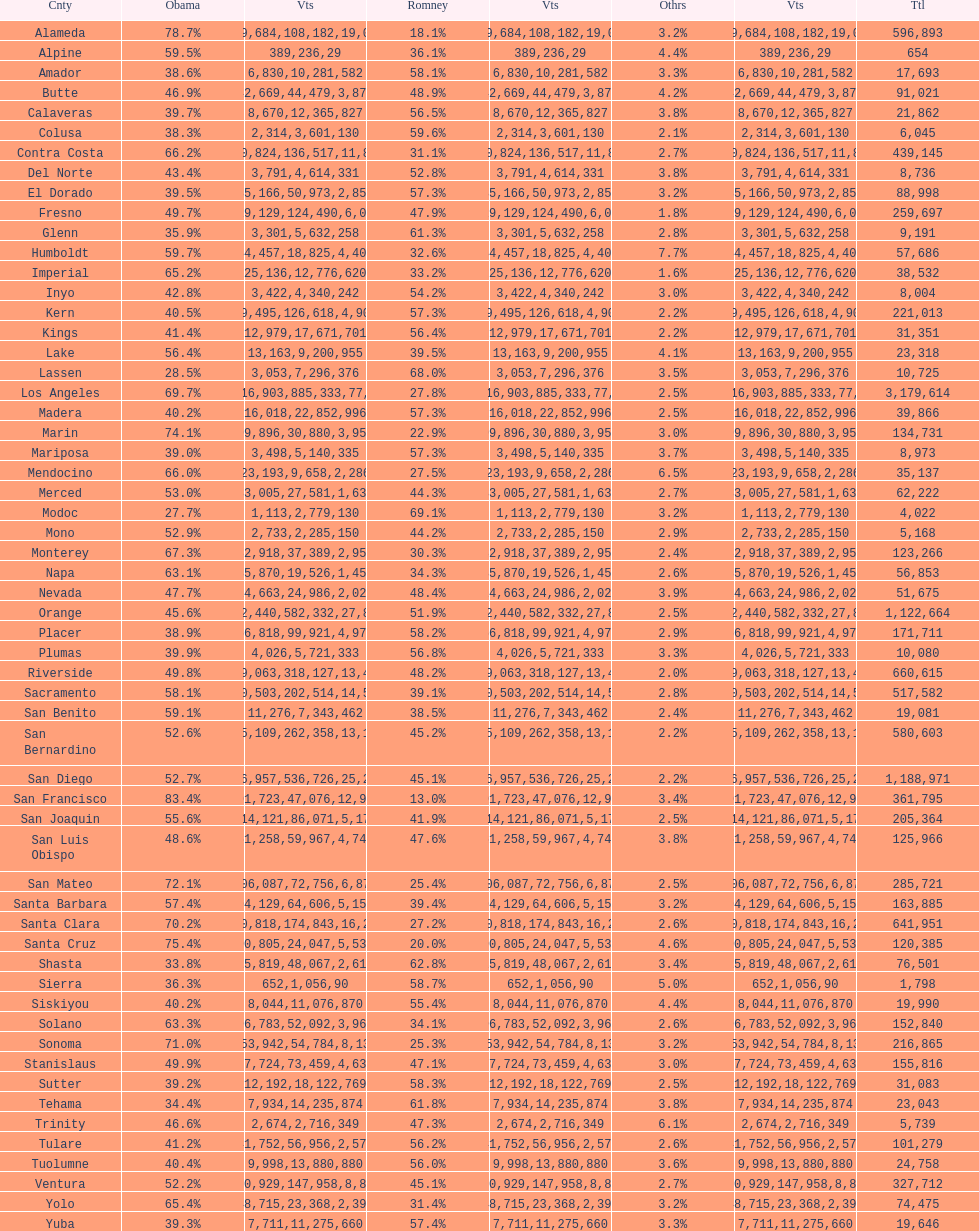What county is just before del norte on the list? Contra Costa. 